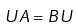Convert formula to latex. <formula><loc_0><loc_0><loc_500><loc_500>U A = B U</formula> 